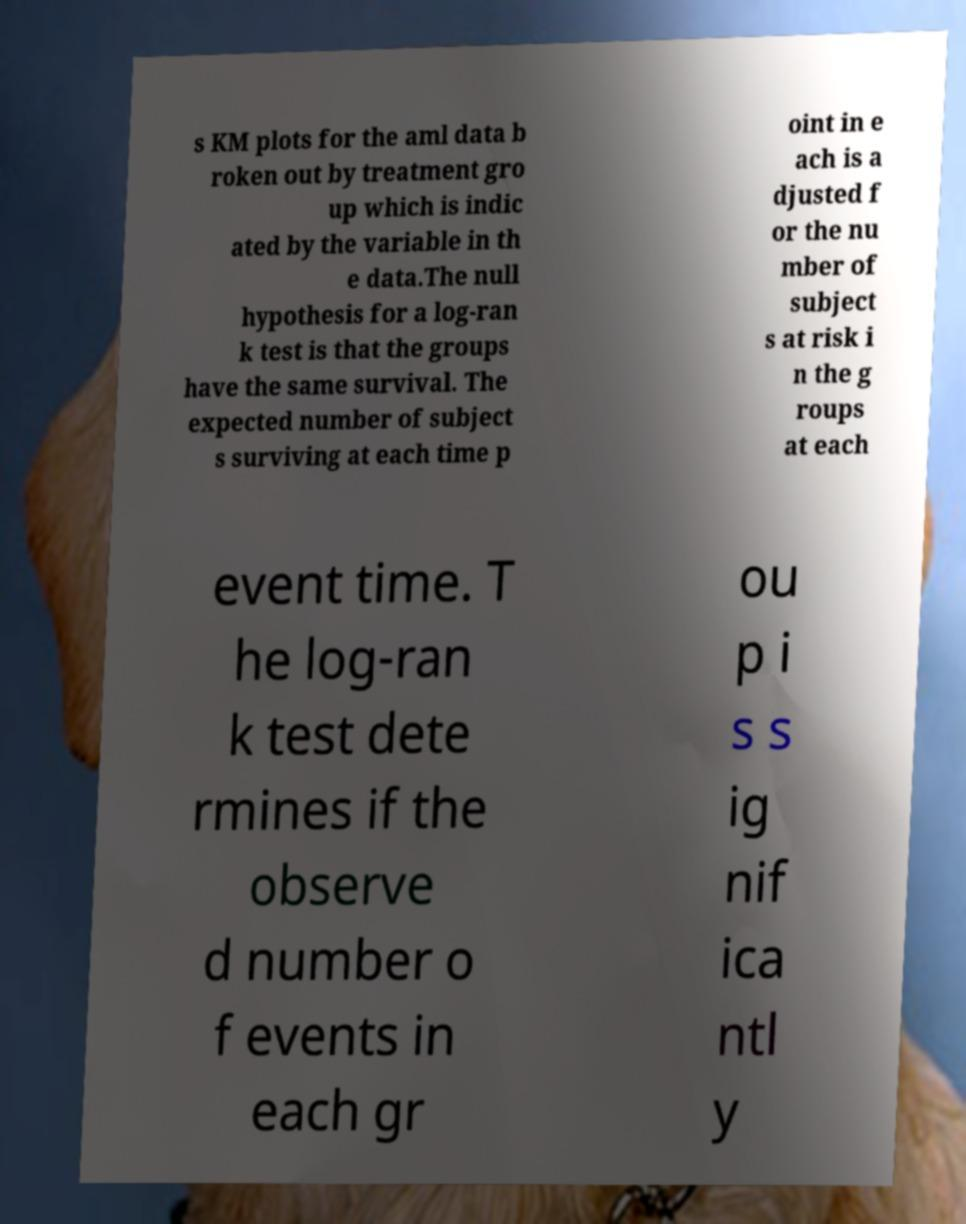For documentation purposes, I need the text within this image transcribed. Could you provide that? s KM plots for the aml data b roken out by treatment gro up which is indic ated by the variable in th e data.The null hypothesis for a log-ran k test is that the groups have the same survival. The expected number of subject s surviving at each time p oint in e ach is a djusted f or the nu mber of subject s at risk i n the g roups at each event time. T he log-ran k test dete rmines if the observe d number o f events in each gr ou p i s s ig nif ica ntl y 